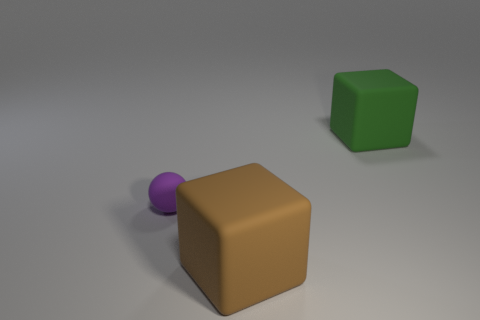Add 3 large brown rubber blocks. How many objects exist? 6 Subtract all spheres. How many objects are left? 2 Add 1 tiny purple balls. How many tiny purple balls are left? 2 Add 1 rubber balls. How many rubber balls exist? 2 Subtract 0 red cubes. How many objects are left? 3 Subtract all tiny green rubber cylinders. Subtract all purple matte objects. How many objects are left? 2 